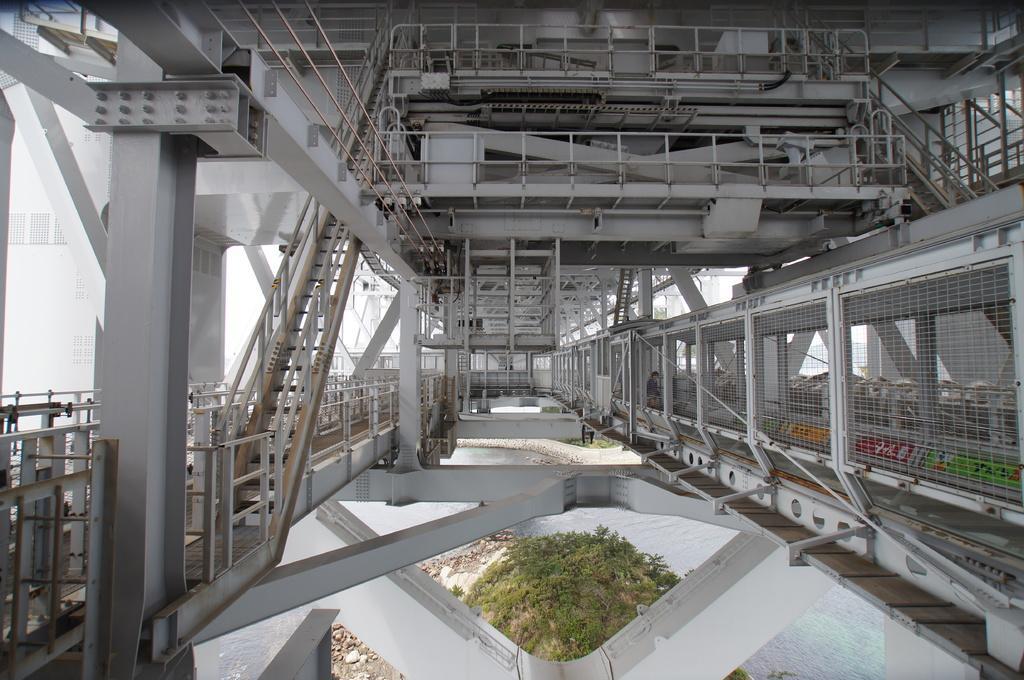Could you give a brief overview of what you see in this image? In this picture, we see a beam or a bridge. Under the bridge, we see water and we even see trees, grass and stones. On the left corner of the picture, we see a building which is white in color. 